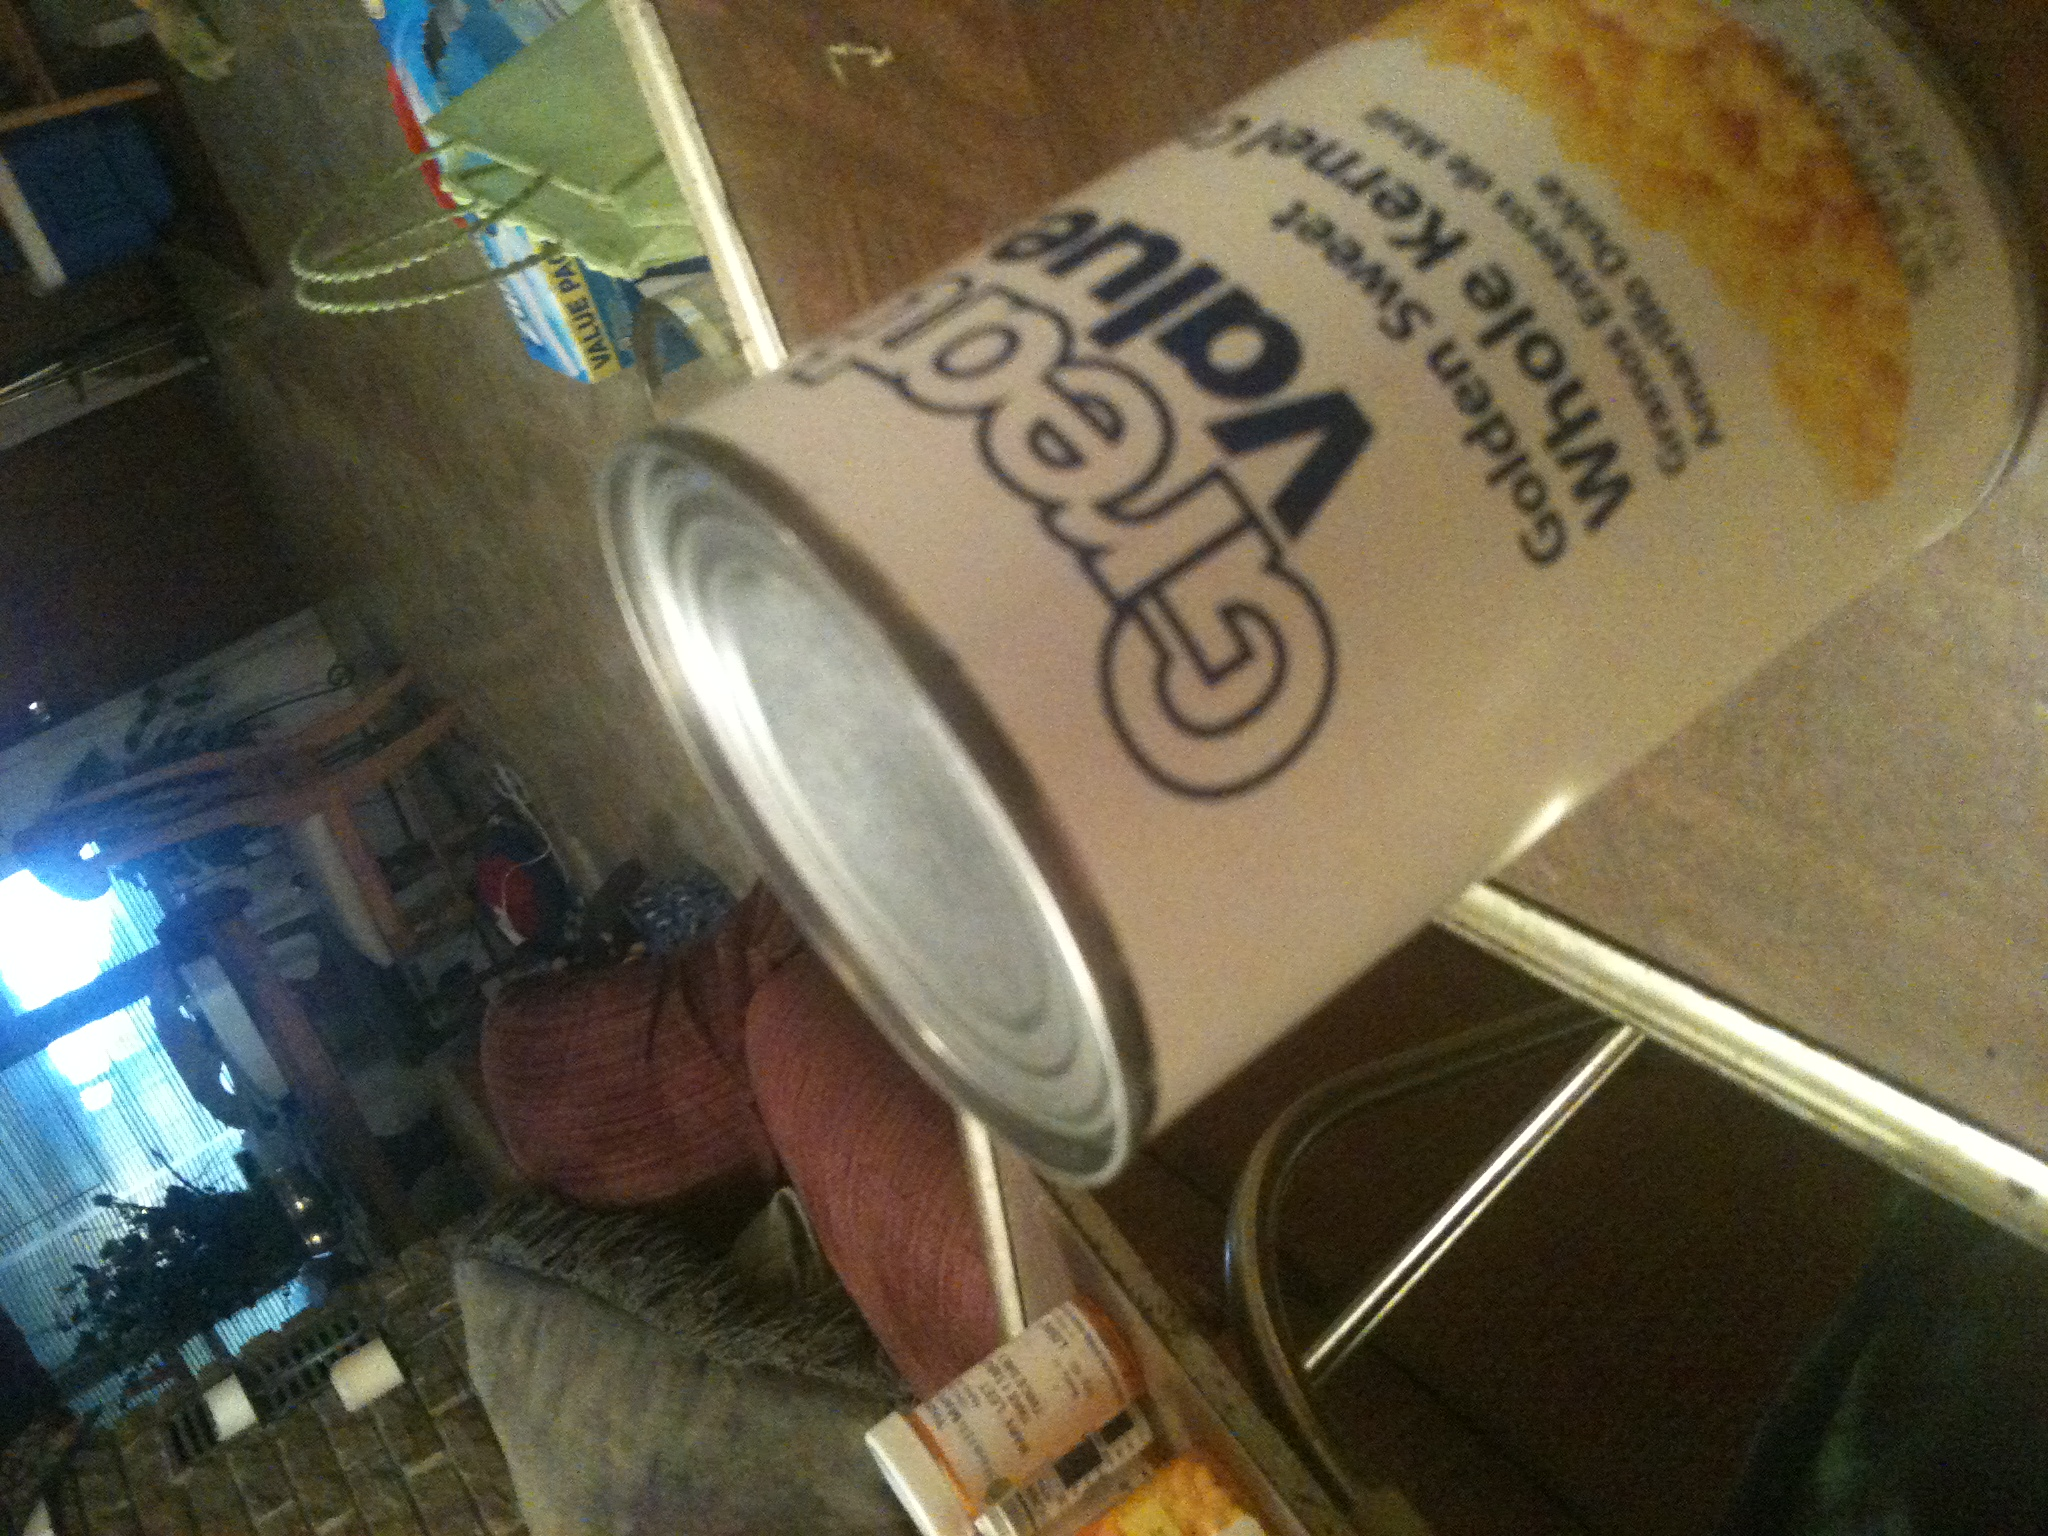What is in this can? from Vizwiz corn 